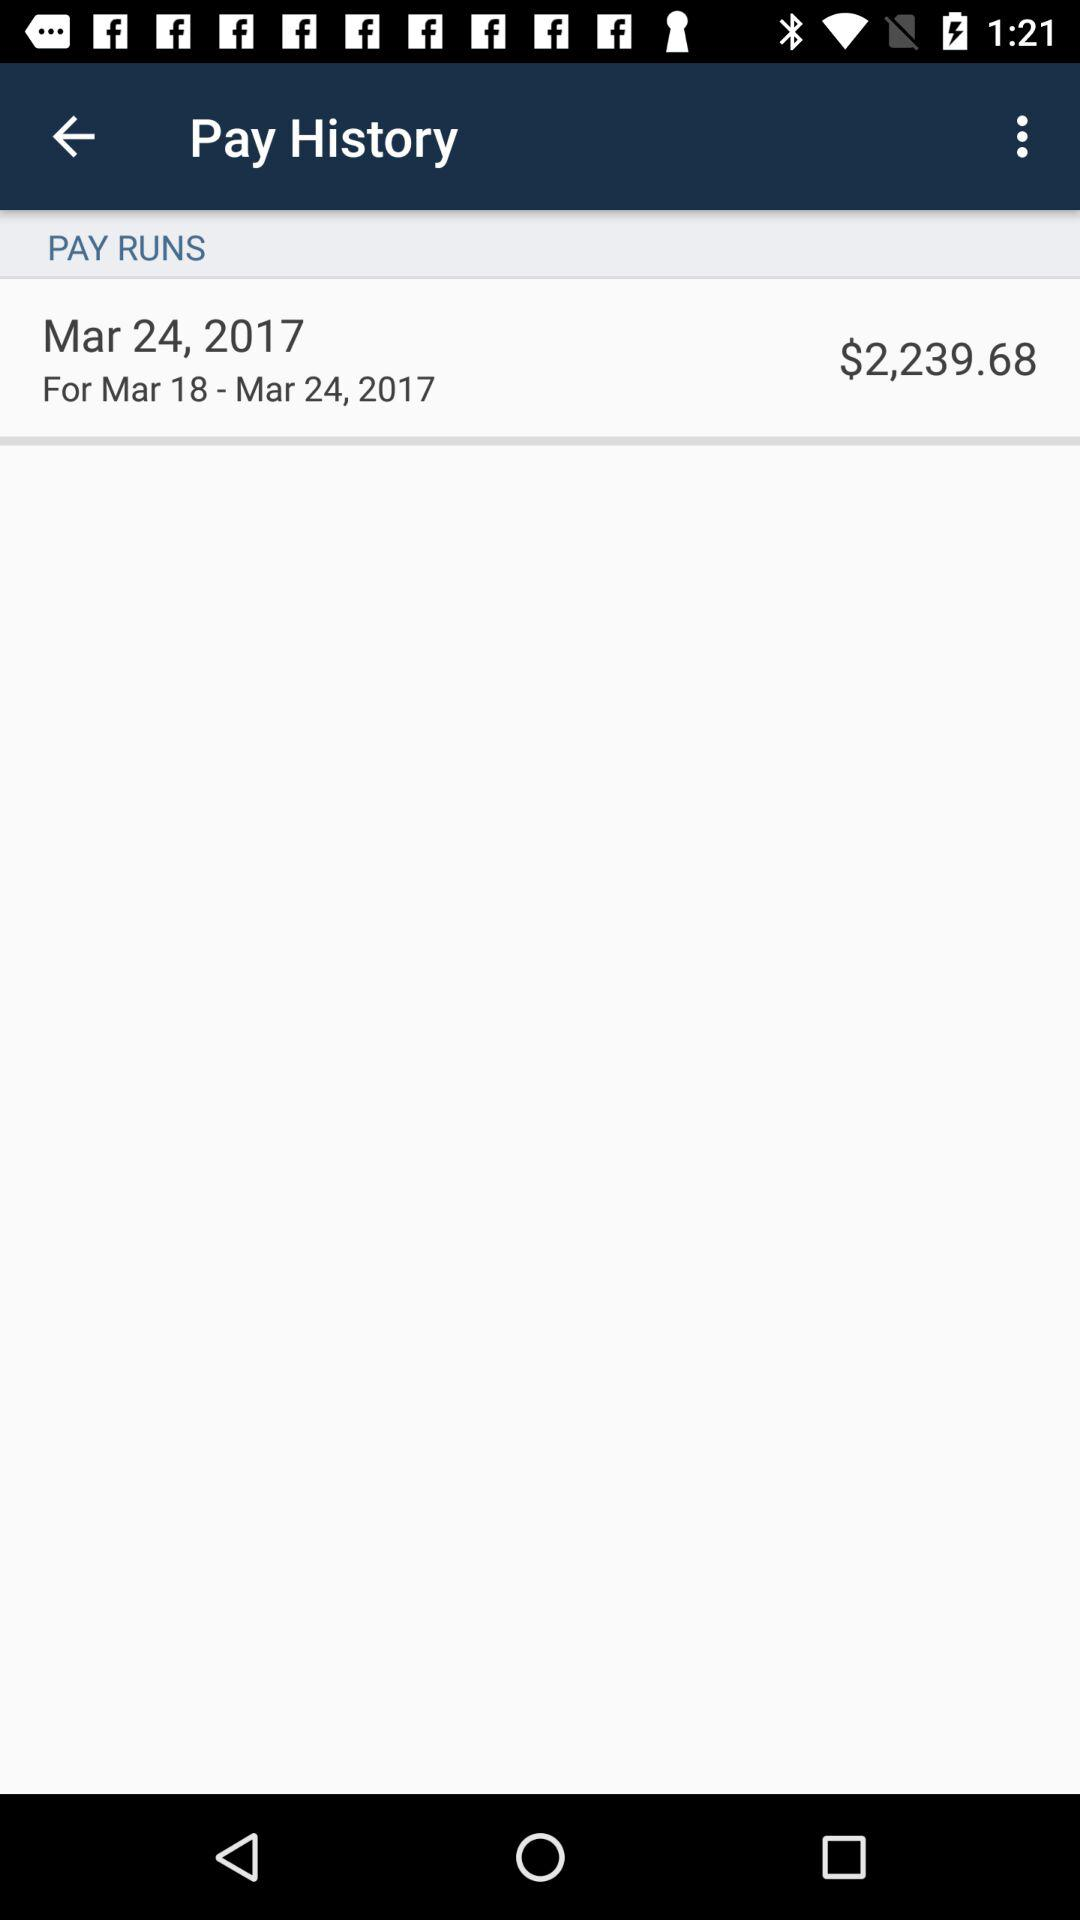How much was the pay for March 18 - 24?
Answer the question using a single word or phrase. $2,239.68 